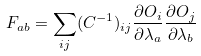Convert formula to latex. <formula><loc_0><loc_0><loc_500><loc_500>F _ { a b } = \sum _ { i j } ( C ^ { - 1 } ) _ { i j } \frac { \partial O _ { i } } { \partial \lambda _ { a } } \frac { \partial O _ { j } } { \partial \lambda _ { b } }</formula> 